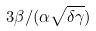Convert formula to latex. <formula><loc_0><loc_0><loc_500><loc_500>3 \beta / ( \alpha \sqrt { \delta \gamma } )</formula> 